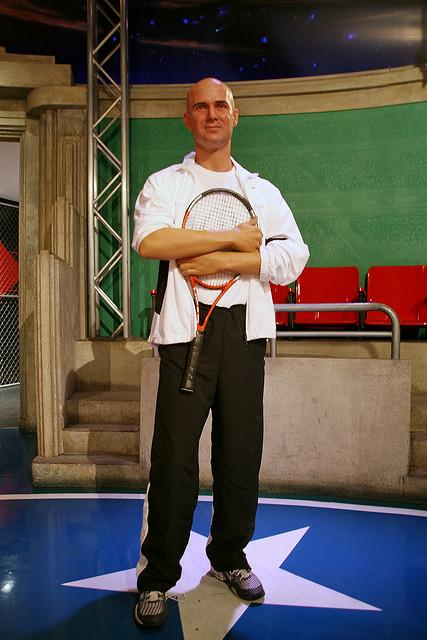What sports equipment is the man holding?

Choices:
A) golf
B) hockey
C) tennis
D) cricket tennis 